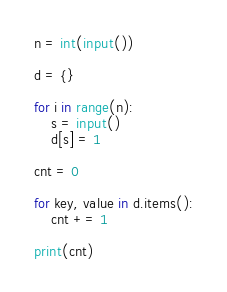<code> <loc_0><loc_0><loc_500><loc_500><_Python_>n = int(input())

d = {}

for i in range(n):
    s = input()
    d[s] = 1

cnt = 0

for key, value in d.items():
    cnt += 1

print(cnt)
</code> 